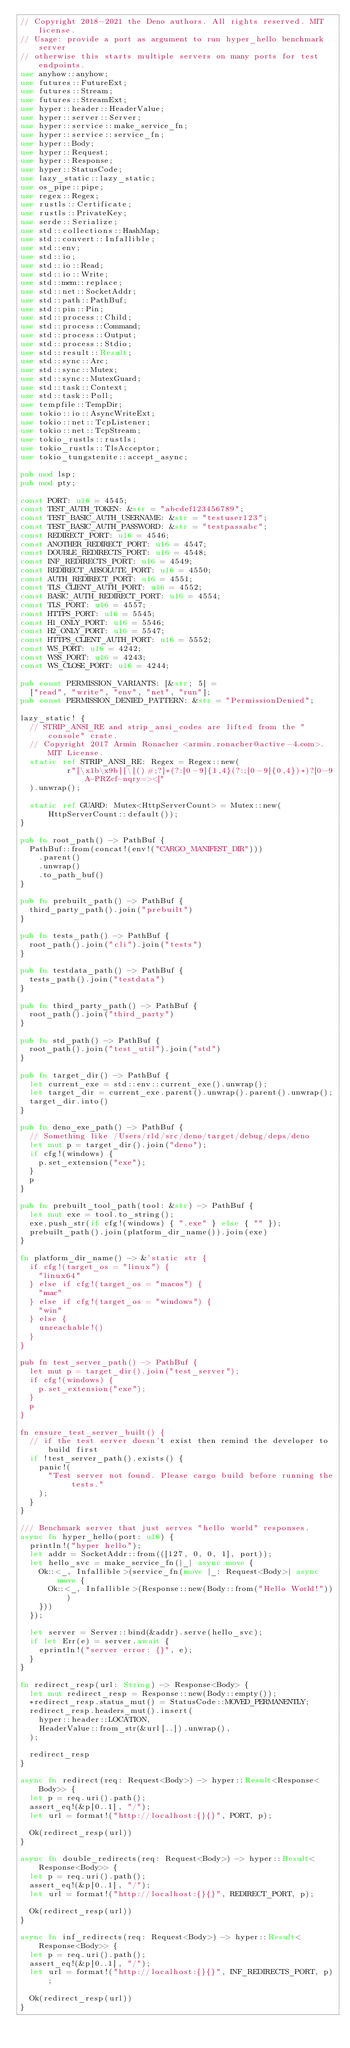<code> <loc_0><loc_0><loc_500><loc_500><_Rust_>// Copyright 2018-2021 the Deno authors. All rights reserved. MIT license.
// Usage: provide a port as argument to run hyper_hello benchmark server
// otherwise this starts multiple servers on many ports for test endpoints.
use anyhow::anyhow;
use futures::FutureExt;
use futures::Stream;
use futures::StreamExt;
use hyper::header::HeaderValue;
use hyper::server::Server;
use hyper::service::make_service_fn;
use hyper::service::service_fn;
use hyper::Body;
use hyper::Request;
use hyper::Response;
use hyper::StatusCode;
use lazy_static::lazy_static;
use os_pipe::pipe;
use regex::Regex;
use rustls::Certificate;
use rustls::PrivateKey;
use serde::Serialize;
use std::collections::HashMap;
use std::convert::Infallible;
use std::env;
use std::io;
use std::io::Read;
use std::io::Write;
use std::mem::replace;
use std::net::SocketAddr;
use std::path::PathBuf;
use std::pin::Pin;
use std::process::Child;
use std::process::Command;
use std::process::Output;
use std::process::Stdio;
use std::result::Result;
use std::sync::Arc;
use std::sync::Mutex;
use std::sync::MutexGuard;
use std::task::Context;
use std::task::Poll;
use tempfile::TempDir;
use tokio::io::AsyncWriteExt;
use tokio::net::TcpListener;
use tokio::net::TcpStream;
use tokio_rustls::rustls;
use tokio_rustls::TlsAcceptor;
use tokio_tungstenite::accept_async;

pub mod lsp;
pub mod pty;

const PORT: u16 = 4545;
const TEST_AUTH_TOKEN: &str = "abcdef123456789";
const TEST_BASIC_AUTH_USERNAME: &str = "testuser123";
const TEST_BASIC_AUTH_PASSWORD: &str = "testpassabc";
const REDIRECT_PORT: u16 = 4546;
const ANOTHER_REDIRECT_PORT: u16 = 4547;
const DOUBLE_REDIRECTS_PORT: u16 = 4548;
const INF_REDIRECTS_PORT: u16 = 4549;
const REDIRECT_ABSOLUTE_PORT: u16 = 4550;
const AUTH_REDIRECT_PORT: u16 = 4551;
const TLS_CLIENT_AUTH_PORT: u16 = 4552;
const BASIC_AUTH_REDIRECT_PORT: u16 = 4554;
const TLS_PORT: u16 = 4557;
const HTTPS_PORT: u16 = 5545;
const H1_ONLY_PORT: u16 = 5546;
const H2_ONLY_PORT: u16 = 5547;
const HTTPS_CLIENT_AUTH_PORT: u16 = 5552;
const WS_PORT: u16 = 4242;
const WSS_PORT: u16 = 4243;
const WS_CLOSE_PORT: u16 = 4244;

pub const PERMISSION_VARIANTS: [&str; 5] =
  ["read", "write", "env", "net", "run"];
pub const PERMISSION_DENIED_PATTERN: &str = "PermissionDenied";

lazy_static! {
  // STRIP_ANSI_RE and strip_ansi_codes are lifted from the "console" crate.
  // Copyright 2017 Armin Ronacher <armin.ronacher@active-4.com>. MIT License.
  static ref STRIP_ANSI_RE: Regex = Regex::new(
          r"[\x1b\x9b][\[()#;?]*(?:[0-9]{1,4}(?:;[0-9]{0,4})*)?[0-9A-PRZcf-nqry=><]"
  ).unwrap();

  static ref GUARD: Mutex<HttpServerCount> = Mutex::new(HttpServerCount::default());
}

pub fn root_path() -> PathBuf {
  PathBuf::from(concat!(env!("CARGO_MANIFEST_DIR")))
    .parent()
    .unwrap()
    .to_path_buf()
}

pub fn prebuilt_path() -> PathBuf {
  third_party_path().join("prebuilt")
}

pub fn tests_path() -> PathBuf {
  root_path().join("cli").join("tests")
}

pub fn testdata_path() -> PathBuf {
  tests_path().join("testdata")
}

pub fn third_party_path() -> PathBuf {
  root_path().join("third_party")
}

pub fn std_path() -> PathBuf {
  root_path().join("test_util").join("std")
}

pub fn target_dir() -> PathBuf {
  let current_exe = std::env::current_exe().unwrap();
  let target_dir = current_exe.parent().unwrap().parent().unwrap();
  target_dir.into()
}

pub fn deno_exe_path() -> PathBuf {
  // Something like /Users/rld/src/deno/target/debug/deps/deno
  let mut p = target_dir().join("deno");
  if cfg!(windows) {
    p.set_extension("exe");
  }
  p
}

pub fn prebuilt_tool_path(tool: &str) -> PathBuf {
  let mut exe = tool.to_string();
  exe.push_str(if cfg!(windows) { ".exe" } else { "" });
  prebuilt_path().join(platform_dir_name()).join(exe)
}

fn platform_dir_name() -> &'static str {
  if cfg!(target_os = "linux") {
    "linux64"
  } else if cfg!(target_os = "macos") {
    "mac"
  } else if cfg!(target_os = "windows") {
    "win"
  } else {
    unreachable!()
  }
}

pub fn test_server_path() -> PathBuf {
  let mut p = target_dir().join("test_server");
  if cfg!(windows) {
    p.set_extension("exe");
  }
  p
}

fn ensure_test_server_built() {
  // if the test server doesn't exist then remind the developer to build first
  if !test_server_path().exists() {
    panic!(
      "Test server not found. Please cargo build before running the tests."
    );
  }
}

/// Benchmark server that just serves "hello world" responses.
async fn hyper_hello(port: u16) {
  println!("hyper hello");
  let addr = SocketAddr::from(([127, 0, 0, 1], port));
  let hello_svc = make_service_fn(|_| async move {
    Ok::<_, Infallible>(service_fn(move |_: Request<Body>| async move {
      Ok::<_, Infallible>(Response::new(Body::from("Hello World!")))
    }))
  });

  let server = Server::bind(&addr).serve(hello_svc);
  if let Err(e) = server.await {
    eprintln!("server error: {}", e);
  }
}

fn redirect_resp(url: String) -> Response<Body> {
  let mut redirect_resp = Response::new(Body::empty());
  *redirect_resp.status_mut() = StatusCode::MOVED_PERMANENTLY;
  redirect_resp.headers_mut().insert(
    hyper::header::LOCATION,
    HeaderValue::from_str(&url[..]).unwrap(),
  );

  redirect_resp
}

async fn redirect(req: Request<Body>) -> hyper::Result<Response<Body>> {
  let p = req.uri().path();
  assert_eq!(&p[0..1], "/");
  let url = format!("http://localhost:{}{}", PORT, p);

  Ok(redirect_resp(url))
}

async fn double_redirects(req: Request<Body>) -> hyper::Result<Response<Body>> {
  let p = req.uri().path();
  assert_eq!(&p[0..1], "/");
  let url = format!("http://localhost:{}{}", REDIRECT_PORT, p);

  Ok(redirect_resp(url))
}

async fn inf_redirects(req: Request<Body>) -> hyper::Result<Response<Body>> {
  let p = req.uri().path();
  assert_eq!(&p[0..1], "/");
  let url = format!("http://localhost:{}{}", INF_REDIRECTS_PORT, p);

  Ok(redirect_resp(url))
}
</code> 